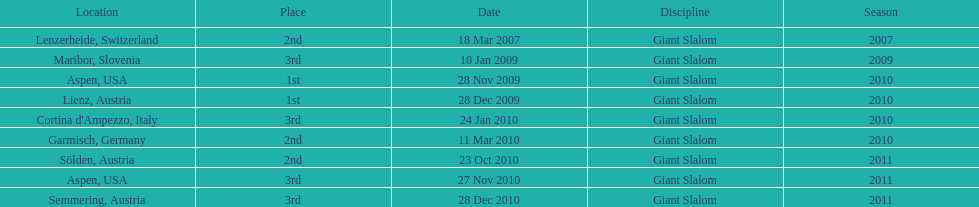Give me the full table as a dictionary. {'header': ['Location', 'Place', 'Date', 'Discipline', 'Season'], 'rows': [['Lenzerheide, Switzerland', '2nd', '18 Mar 2007', 'Giant Slalom', '2007'], ['Maribor, Slovenia', '3rd', '10 Jan 2009', 'Giant Slalom', '2009'], ['Aspen, USA', '1st', '28 Nov 2009', 'Giant Slalom', '2010'], ['Lienz, Austria', '1st', '28 Dec 2009', 'Giant Slalom', '2010'], ["Cortina d'Ampezzo, Italy", '3rd', '24 Jan 2010', 'Giant Slalom', '2010'], ['Garmisch, Germany', '2nd', '11 Mar 2010', 'Giant Slalom', '2010'], ['Sölden, Austria', '2nd', '23 Oct 2010', 'Giant Slalom', '2011'], ['Aspen, USA', '3rd', '27 Nov 2010', 'Giant Slalom', '2011'], ['Semmering, Austria', '3rd', '28 Dec 2010', 'Giant Slalom', '2011']]} What was the finishing place of the last race in december 2010? 3rd. 